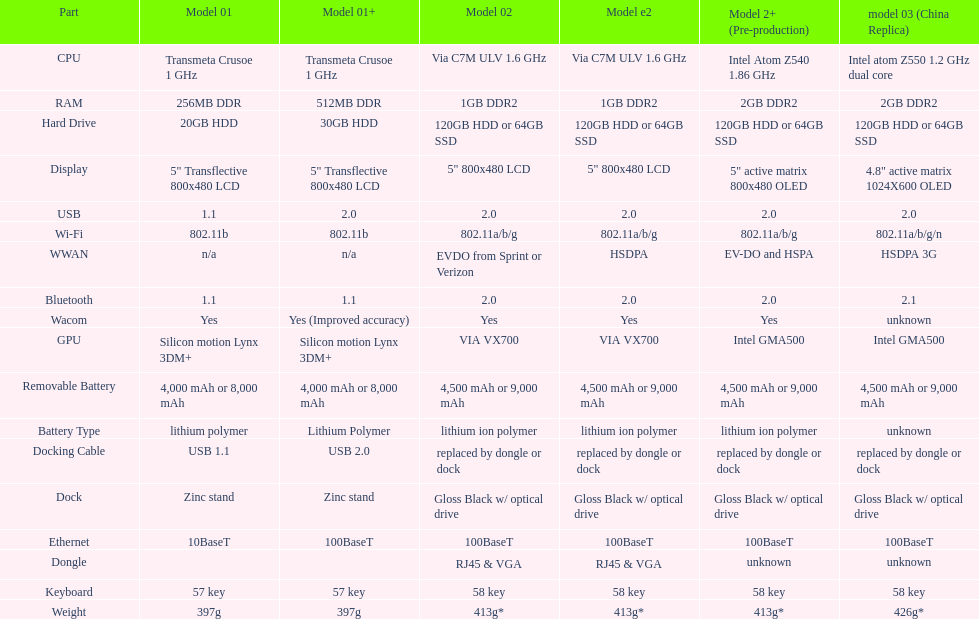What is the average number of models that have usb 2.0? 5. 